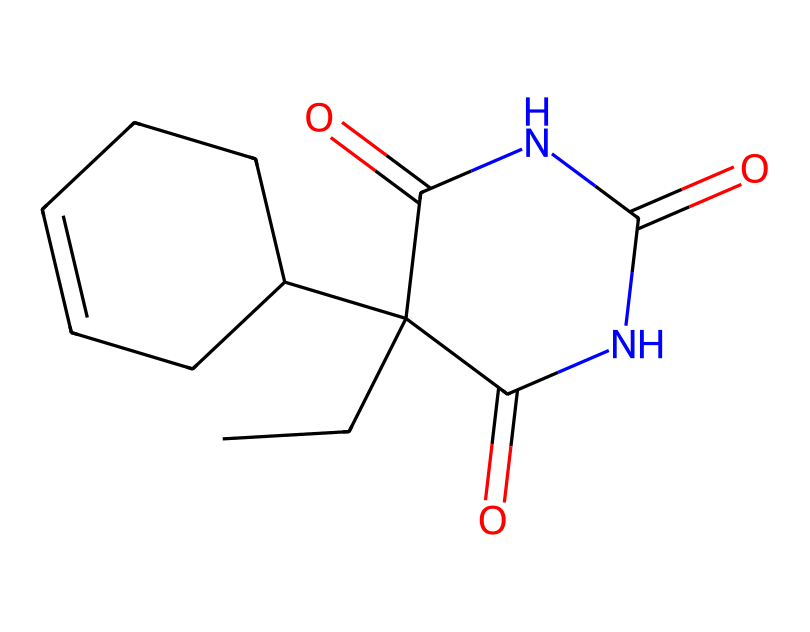What is the molecular formula of cyclobarbital? To derive the molecular formula, you count the number of carbon (C), hydrogen (H), nitrogen (N), and oxygen (O) atoms present in the SMILES representation. The counting results in 12 carbons, 14 hydrogens, 4 nitrogens, and 3 oxygens. Thus, the molecular formula is C12H14N4O3.
Answer: C12H14N4O3 How many rings are present in cyclobarbital? By analyzing the structure represented in the SMILES, we identify that there are two distinct cyclic structures indicated by the characters 'C1' and 'C2'. Therefore, there are two rings in cyclobarbital.
Answer: 2 What type of functional group is present due to the 'NC(=O)' in the structure? The 'NC(=O)' suggests the presence of an amide functional group (C=O directly attached to a nitrogen atom). This can be concluded from recognizing the carbonyl (C=O) and nitrogen attachment.
Answer: amide Which atom serves as the central atom in the cycloalkane portion? In the cycloalkane part of the structure, the central atom connected to the other carbon atoms in the cyclobarbital is carbon, as it forms the core of the ring structure.
Answer: carbon Does cyclobarbital contain any heteroatoms? Heteroatoms are those atoms in a molecule other than carbon and hydrogen. In cyclobarbital, we observe both nitrogen and oxygen, which qualify as heteroatoms. Hence, this chemical does contain heteroatoms.
Answer: yes What type of compound is cyclobarbital classified as? Cyclobarbital is classified as a sedative, which is indicated by its intended use and its structural components, including the cycloalkane structure paired with specific functional groups suggesting sedative properties.
Answer: sedative 